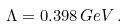<formula> <loc_0><loc_0><loc_500><loc_500>\Lambda = 0 . 3 9 8 \, G e V \, .</formula> 